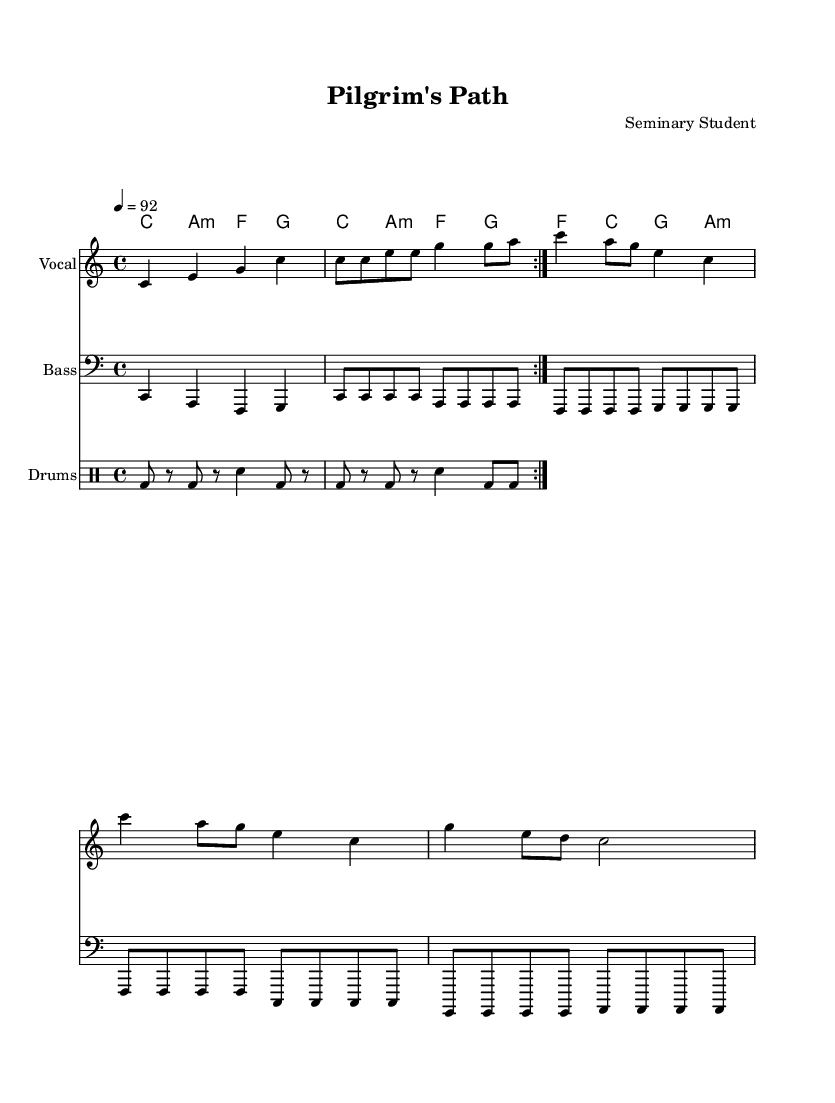What is the key signature of this music? The key signature appears at the beginning of the staff and indicates the key of C major, which has no sharps or flats.
Answer: C major What is the time signature of this piece? The time signature is indicated at the beginning of the music as 4/4, meaning there are four beats in a measure and a quarter note gets one beat.
Answer: 4/4 What is the tempo marking for this composition? The tempo marking is shown as 4 = 92, indicating that the quarter note is set to a tempo of 92 beats per minute.
Answer: 92 How many measures are in the verse section? By counting the measures in the verse segment of the melody, I find there are 4 measures in total.
Answer: 4 What type of rhythm pattern does the drum section follow? The drum section indicates a repeated section with bass drum hits and snares, creating a typical hip-hop feel through its pattern.
Answer: Hip-hop What is the main theme discussed in the lyrics? The lyrics focus on religious history and theology, reflecting on figures such as Augustine and Aquinas, and emphasizing learning and spreading the Word.
Answer: Religious history What does the chorus emphasize in the context of the rap? The chorus highlights the intention of bringing the message through rap, implying active participation in learning and teaching through music.
Answer: Spreading the Word 